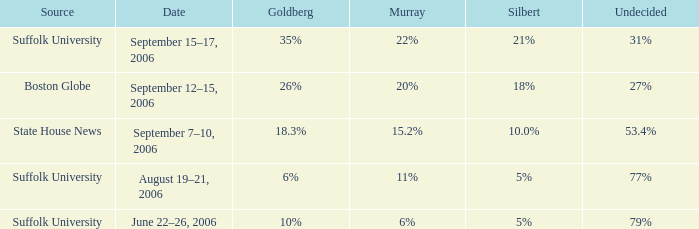What is the date of the poll with Silbert at 10.0%? September 7–10, 2006. 